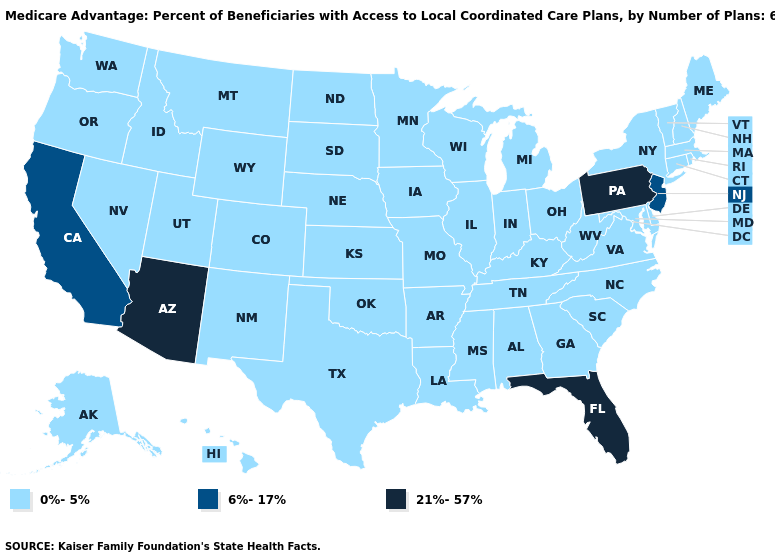Does the map have missing data?
Short answer required. No. What is the lowest value in the West?
Concise answer only. 0%-5%. What is the value of Oklahoma?
Give a very brief answer. 0%-5%. Name the states that have a value in the range 21%-57%?
Short answer required. Arizona, Florida, Pennsylvania. Among the states that border Kansas , which have the lowest value?
Write a very short answer. Colorado, Missouri, Nebraska, Oklahoma. What is the lowest value in the Northeast?
Write a very short answer. 0%-5%. Among the states that border Colorado , does Nebraska have the highest value?
Write a very short answer. No. Which states hav the highest value in the Northeast?
Write a very short answer. Pennsylvania. Among the states that border Oregon , which have the highest value?
Short answer required. California. What is the highest value in the West ?
Concise answer only. 21%-57%. 